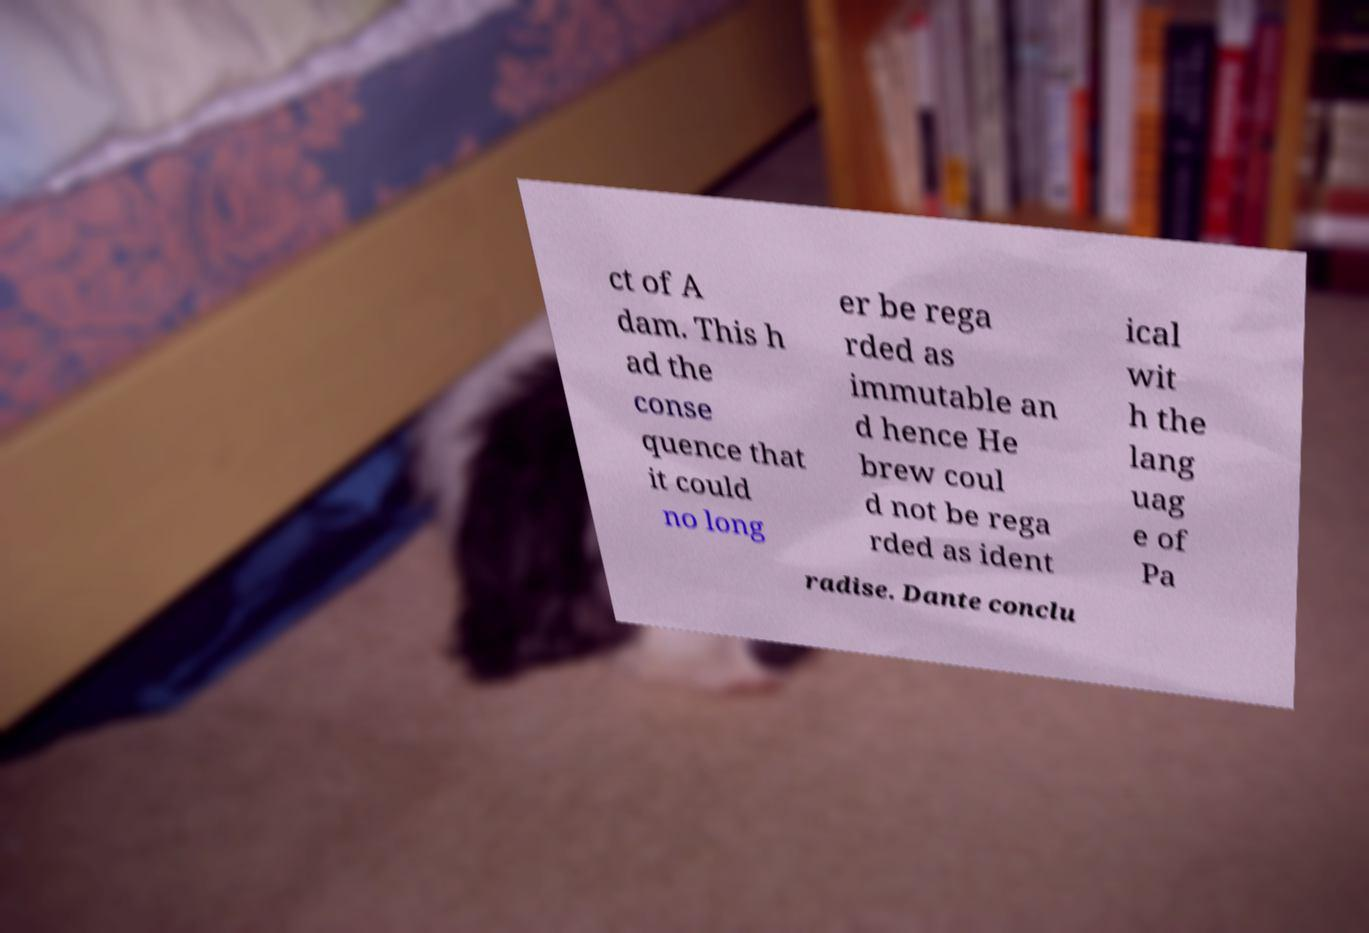I need the written content from this picture converted into text. Can you do that? ct of A dam. This h ad the conse quence that it could no long er be rega rded as immutable an d hence He brew coul d not be rega rded as ident ical wit h the lang uag e of Pa radise. Dante conclu 